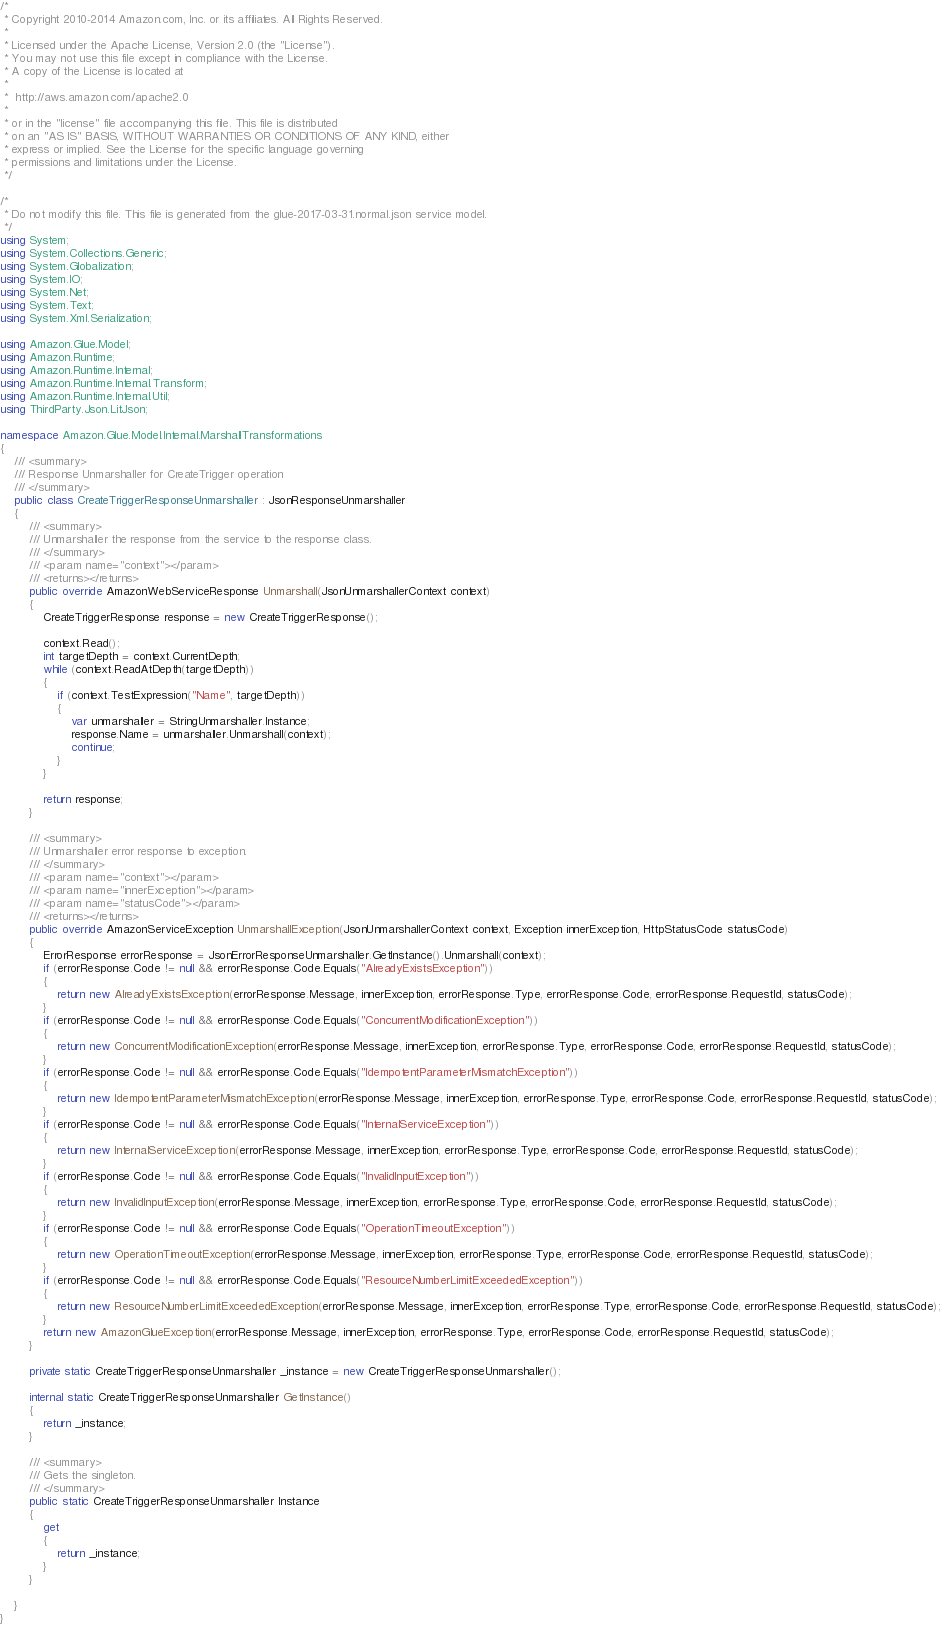Convert code to text. <code><loc_0><loc_0><loc_500><loc_500><_C#_>/*
 * Copyright 2010-2014 Amazon.com, Inc. or its affiliates. All Rights Reserved.
 * 
 * Licensed under the Apache License, Version 2.0 (the "License").
 * You may not use this file except in compliance with the License.
 * A copy of the License is located at
 * 
 *  http://aws.amazon.com/apache2.0
 * 
 * or in the "license" file accompanying this file. This file is distributed
 * on an "AS IS" BASIS, WITHOUT WARRANTIES OR CONDITIONS OF ANY KIND, either
 * express or implied. See the License for the specific language governing
 * permissions and limitations under the License.
 */

/*
 * Do not modify this file. This file is generated from the glue-2017-03-31.normal.json service model.
 */
using System;
using System.Collections.Generic;
using System.Globalization;
using System.IO;
using System.Net;
using System.Text;
using System.Xml.Serialization;

using Amazon.Glue.Model;
using Amazon.Runtime;
using Amazon.Runtime.Internal;
using Amazon.Runtime.Internal.Transform;
using Amazon.Runtime.Internal.Util;
using ThirdParty.Json.LitJson;

namespace Amazon.Glue.Model.Internal.MarshallTransformations
{
    /// <summary>
    /// Response Unmarshaller for CreateTrigger operation
    /// </summary>  
    public class CreateTriggerResponseUnmarshaller : JsonResponseUnmarshaller
    {
        /// <summary>
        /// Unmarshaller the response from the service to the response class.
        /// </summary>  
        /// <param name="context"></param>
        /// <returns></returns>
        public override AmazonWebServiceResponse Unmarshall(JsonUnmarshallerContext context)
        {
            CreateTriggerResponse response = new CreateTriggerResponse();

            context.Read();
            int targetDepth = context.CurrentDepth;
            while (context.ReadAtDepth(targetDepth))
            {
                if (context.TestExpression("Name", targetDepth))
                {
                    var unmarshaller = StringUnmarshaller.Instance;
                    response.Name = unmarshaller.Unmarshall(context);
                    continue;
                }
            }

            return response;
        }

        /// <summary>
        /// Unmarshaller error response to exception.
        /// </summary>  
        /// <param name="context"></param>
        /// <param name="innerException"></param>
        /// <param name="statusCode"></param>
        /// <returns></returns>
        public override AmazonServiceException UnmarshallException(JsonUnmarshallerContext context, Exception innerException, HttpStatusCode statusCode)
        {
            ErrorResponse errorResponse = JsonErrorResponseUnmarshaller.GetInstance().Unmarshall(context);
            if (errorResponse.Code != null && errorResponse.Code.Equals("AlreadyExistsException"))
            {
                return new AlreadyExistsException(errorResponse.Message, innerException, errorResponse.Type, errorResponse.Code, errorResponse.RequestId, statusCode);
            }
            if (errorResponse.Code != null && errorResponse.Code.Equals("ConcurrentModificationException"))
            {
                return new ConcurrentModificationException(errorResponse.Message, innerException, errorResponse.Type, errorResponse.Code, errorResponse.RequestId, statusCode);
            }
            if (errorResponse.Code != null && errorResponse.Code.Equals("IdempotentParameterMismatchException"))
            {
                return new IdempotentParameterMismatchException(errorResponse.Message, innerException, errorResponse.Type, errorResponse.Code, errorResponse.RequestId, statusCode);
            }
            if (errorResponse.Code != null && errorResponse.Code.Equals("InternalServiceException"))
            {
                return new InternalServiceException(errorResponse.Message, innerException, errorResponse.Type, errorResponse.Code, errorResponse.RequestId, statusCode);
            }
            if (errorResponse.Code != null && errorResponse.Code.Equals("InvalidInputException"))
            {
                return new InvalidInputException(errorResponse.Message, innerException, errorResponse.Type, errorResponse.Code, errorResponse.RequestId, statusCode);
            }
            if (errorResponse.Code != null && errorResponse.Code.Equals("OperationTimeoutException"))
            {
                return new OperationTimeoutException(errorResponse.Message, innerException, errorResponse.Type, errorResponse.Code, errorResponse.RequestId, statusCode);
            }
            if (errorResponse.Code != null && errorResponse.Code.Equals("ResourceNumberLimitExceededException"))
            {
                return new ResourceNumberLimitExceededException(errorResponse.Message, innerException, errorResponse.Type, errorResponse.Code, errorResponse.RequestId, statusCode);
            }
            return new AmazonGlueException(errorResponse.Message, innerException, errorResponse.Type, errorResponse.Code, errorResponse.RequestId, statusCode);
        }

        private static CreateTriggerResponseUnmarshaller _instance = new CreateTriggerResponseUnmarshaller();        

        internal static CreateTriggerResponseUnmarshaller GetInstance()
        {
            return _instance;
        }

        /// <summary>
        /// Gets the singleton.
        /// </summary>  
        public static CreateTriggerResponseUnmarshaller Instance
        {
            get
            {
                return _instance;
            }
        }

    }
}</code> 